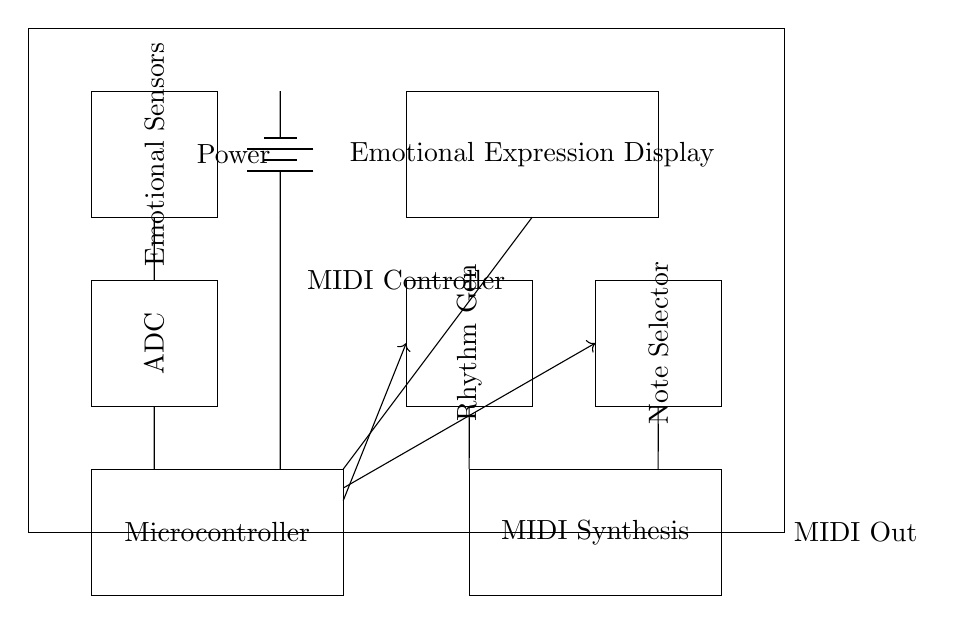What are the main components of the MIDI controller? The main components are the emotional sensors, ADC, microcontroller, MIDI synthesis module, rhythm generator, note selector, and display. Each component serves a specific function for translating emotional inputs into musical outputs.
Answer: emotional sensors, ADC, microcontroller, MIDI synthesis module, rhythm generator, note selector, display What does the power supply provide? The power supply provides electrical energy required to operate the components within the MIDI controller, ensuring they function correctly. The component labeled as “Power” indicates this within the circuit.
Answer: electrical energy How many modules are involved in sound generation? There are three distinct modules that contribute to sound generation: the rhythm generator, note selector, and MIDI synthesis module. Each module plays a role in creating the music from inputs.
Answer: three What is the role of the ADC? The ADC, or Analog-to-Digital Converter, translates the analog signals from the emotional sensors into digital signals that the microcontroller can process. This conversion is crucial for interacting with digital components.
Answer: translates signals Which component receives the output from the microcontroller? The component that receives output from the microcontroller is the MIDI synthesis module. It takes the processed digital signals and produces corresponding MIDI data for further musical synthesis.
Answer: MIDI synthesis module Why are there control signals coming from the microcontroller? The control signals are necessary for directing the flow of data from the microcontroller to both the rhythm generator and note selector. This allows the system to organize how the inputs are converted into musical outputs.
Answer: to direct data flow What is displayed on the emotional expression display? The emotional expression display shows the processed emotional inputs in a visual format, likely indicating the type or intensity of emotions detected by the emotional sensors, helping users understand the emotional input received.
Answer: processed emotional inputs 